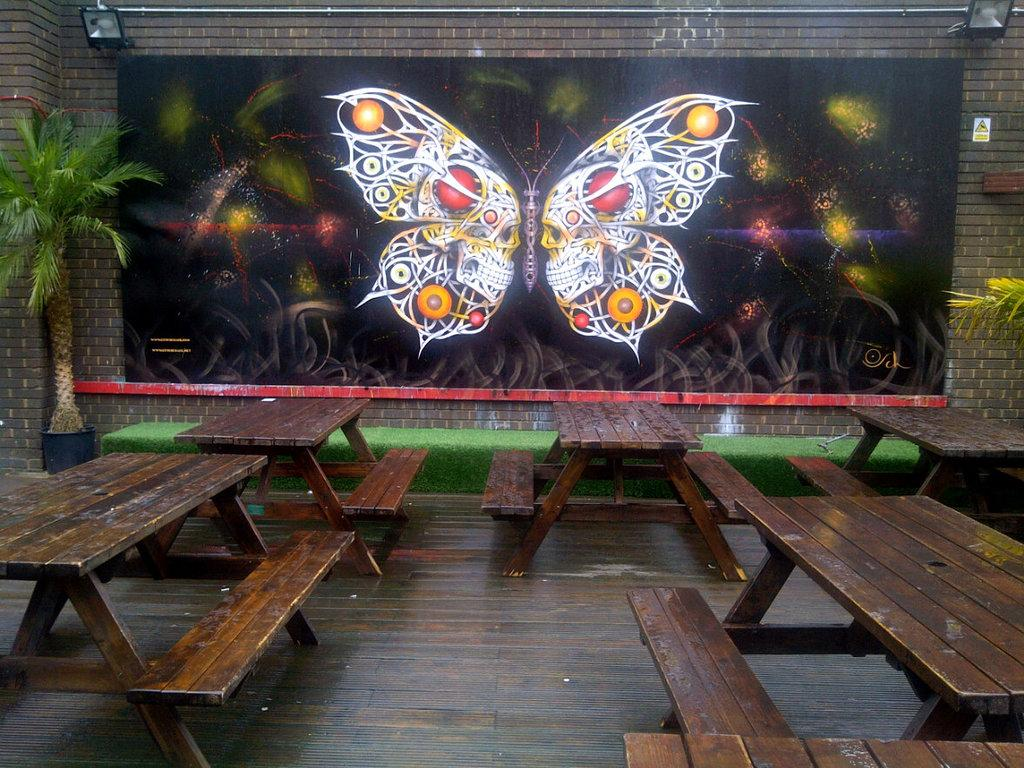What type of seating is visible in the image? There are benches in the image. What is hanging on the wall in front of the benches? There is a butterfly poster on the wall in front of the benches. What is positioned above the poster? There are two focus lights above the poster. What type of vegetation can be seen in the image? There are two trees in the image. What direction is the bone pointing in the image? There is no bone present in the image. How many copies of the butterfly poster are there in the image? There is only one butterfly poster in the image. 